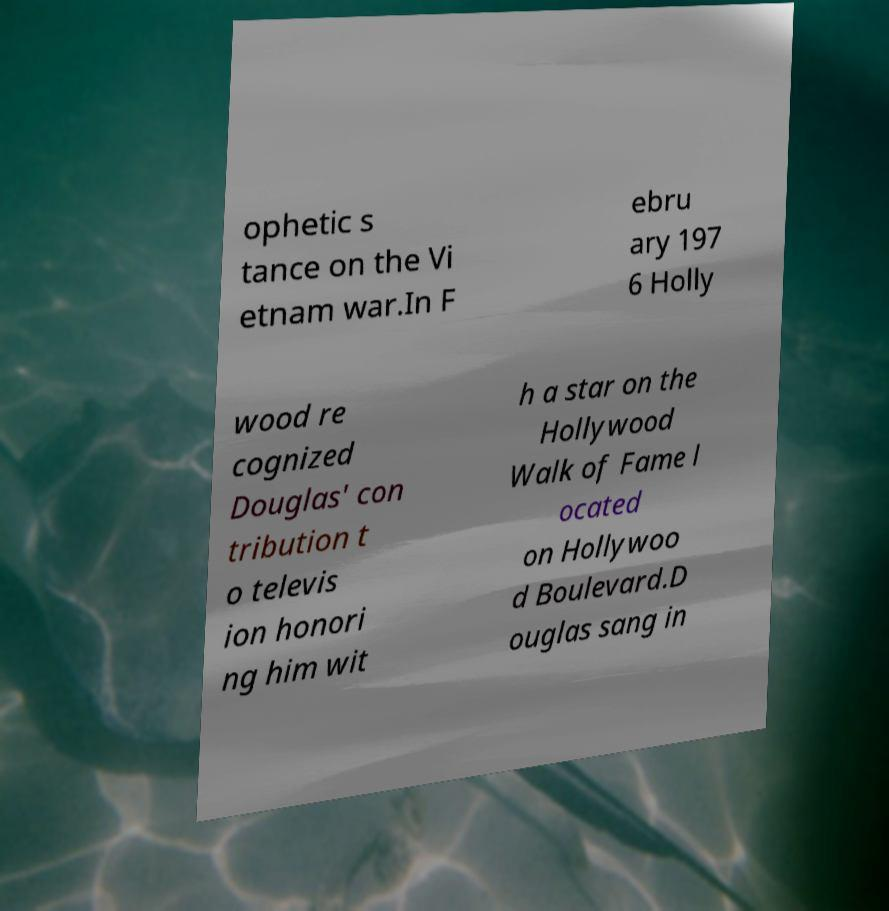Could you assist in decoding the text presented in this image and type it out clearly? ophetic s tance on the Vi etnam war.In F ebru ary 197 6 Holly wood re cognized Douglas' con tribution t o televis ion honori ng him wit h a star on the Hollywood Walk of Fame l ocated on Hollywoo d Boulevard.D ouglas sang in 